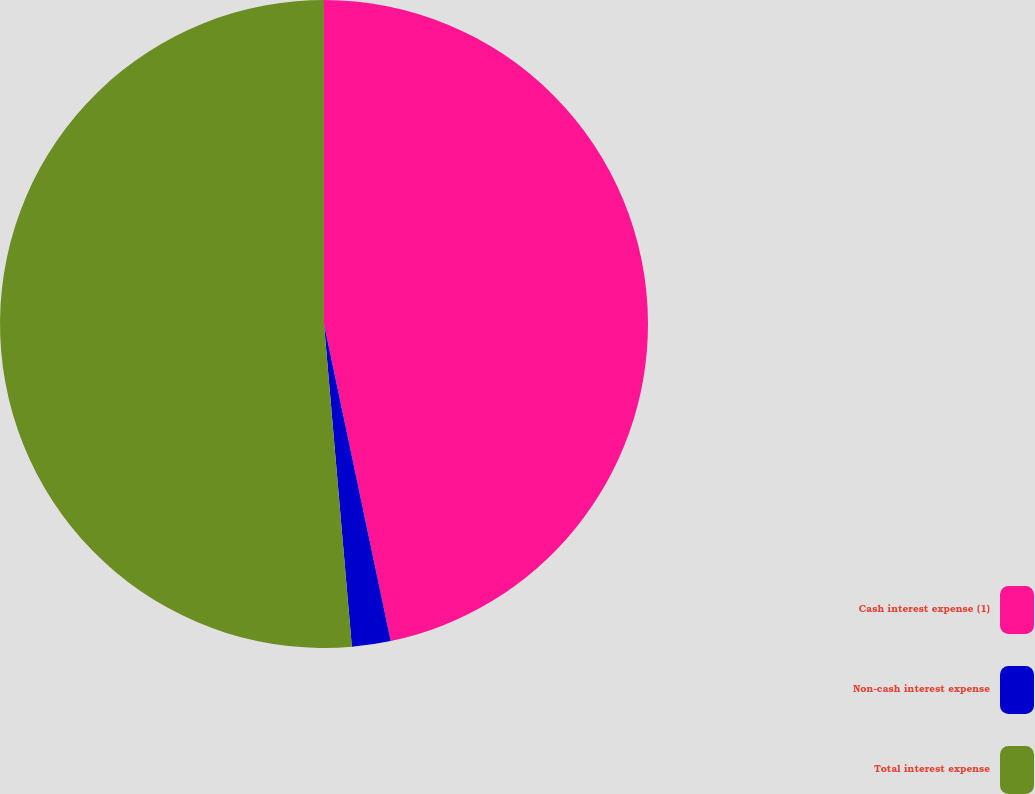<chart> <loc_0><loc_0><loc_500><loc_500><pie_chart><fcel>Cash interest expense (1)<fcel>Non-cash interest expense<fcel>Total interest expense<nl><fcel>46.7%<fcel>1.93%<fcel>51.37%<nl></chart> 